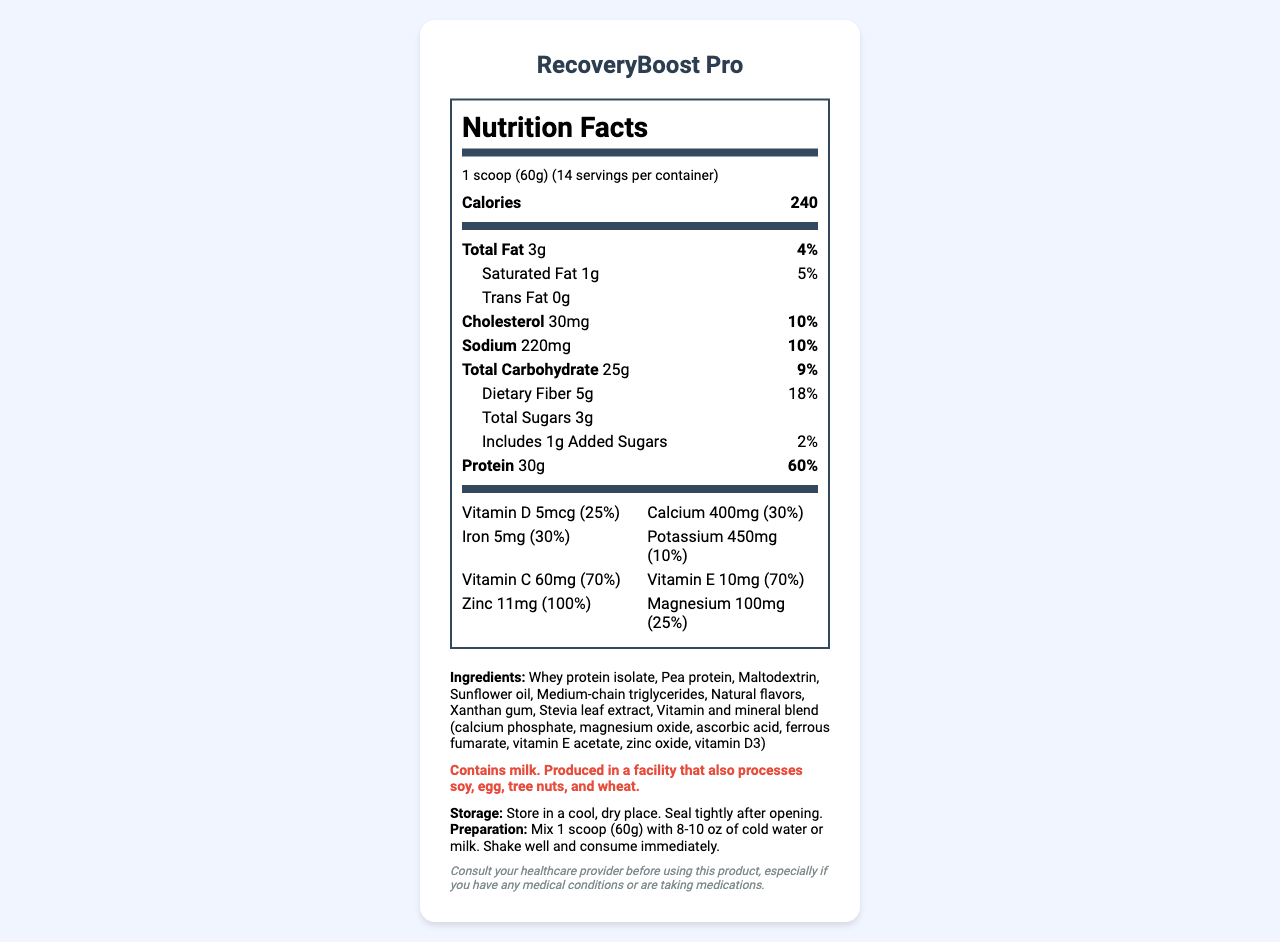what is the serving size? The serving size is listed at the beginning of the nutrition facts, specifying that one scoop is equal to 60 grams.
Answer: 1 scoop (60g) how many servings are in one container? The container has 14 servings as indicated in the section near the top of the nutrition facts.
Answer: 14 how many calories per serving? The calorie content per serving is 240, clearly stated in the bold section labeled "Calories."
Answer: 240 what is the total fat content per serving? The total fat content per serving is 3 grams, as shown in the 'Total Fat' section.
Answer: 3g how much protein is there per serving and what percentage of the daily value does it fulfill? The protein content is 30 grams per serving, which represents 60% of the daily value.
Answer: 30g, 60% what is the percentage daily value of saturated fat per serving? The saturated fat daily value percentage is listed as 5%.
Answer: 5% how much calcium is in each serving? Each serving contains 400mg of calcium, as noted in the vitamins and minerals section.
Answer: 400mg what allergens are present in this product? The allergen information section explicitly states the allergens present in or around the product.
Answer: Contains milk. Produced in a facility that also processes soy, egg, tree nuts, and wheat. what are some key product features? The product features are listed at the end, highlighting the high protein content, vitamin and mineral enhancements, easy-to-digest formula, and clinical testing for absorption.
Answer: High protein content, enhanced with vitamins and minerals, easy to digest, clinically tested for optimal absorption which of the following is NOT an ingredient in RecoveryBoost Pro? A. Whey protein isolate B. Soy protein C. Xanthan gum D. Pea protein Soy protein is not listed as an ingredient in RecoveryBoost Pro.
Answer: B which vitamin provides the highest percentage of the daily value? A. Vitamin D B. Vitamin C C. Vitamin E D. Zinc Zinc provides 100% of the daily value, the highest among the listed vitamins.
Answer: D should you consult a healthcare provider before using this product? (Yes/No) The medical disclaimer advises consulting a healthcare provider, especially if you have medical conditions or are taking medications.
Answer: Yes summarize the main benefits and usage of the RecoveryBoost Pro product. The summary encapsulates the product's main benefits including its nutrient content, targeted audience, ease of digestion, and clinical validation.
Answer: RecoveryBoost Pro is a high-protein meal replacement shake designed for post-surgery recovery patients. It contains 30g of protein per serving, along with a blend of essential vitamins and minerals to support muscle recovery and immune function. The product is easy to digest and has been clinically tested for optimal absorption. how is this product prepared for consumption? The preparation instructions specify mixing the product with 8-10 oz of cold water or milk, shaking it well, and consuming it immediately.
Answer: Mix 1 scoop (60g) with 8-10 oz of cold water or milk. Shake well and consume immediately. what is the manufacturer's name? The manufacturer's name is mentioned at the end of the document.
Answer: TechMed Nutrition, a division of Advanced Medical Supplies, Inc. how much dietary fiber is in each serving? Each serving contains 5 grams of dietary fiber, as listed under the dietary fiber section.
Answer: 5g how should this product be stored? The storage instructions indicate keeping the product in a cool, dry place and sealing it tightly after opening.
Answer: Store in a cool, dry place. Seal tightly after opening. does RecoveryBoost Pro contain any added sugars? The nutrition facts list 1g of added sugars per serving.
Answer: Yes what is the source of the unspecified 'natural flavors' in the ingredients? The document does not provide specific information about the source of the 'natural flavors' listed in the ingredients.
Answer: Cannot be determined 